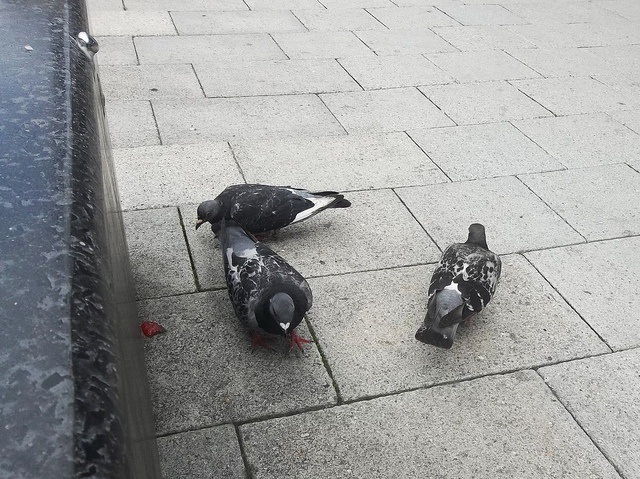Describe the objects in this image and their specific colors. I can see bird in darkgray, black, and gray tones, bird in darkgray, black, gray, and lightgray tones, and bird in darkgray, black, gray, and lightgray tones in this image. 